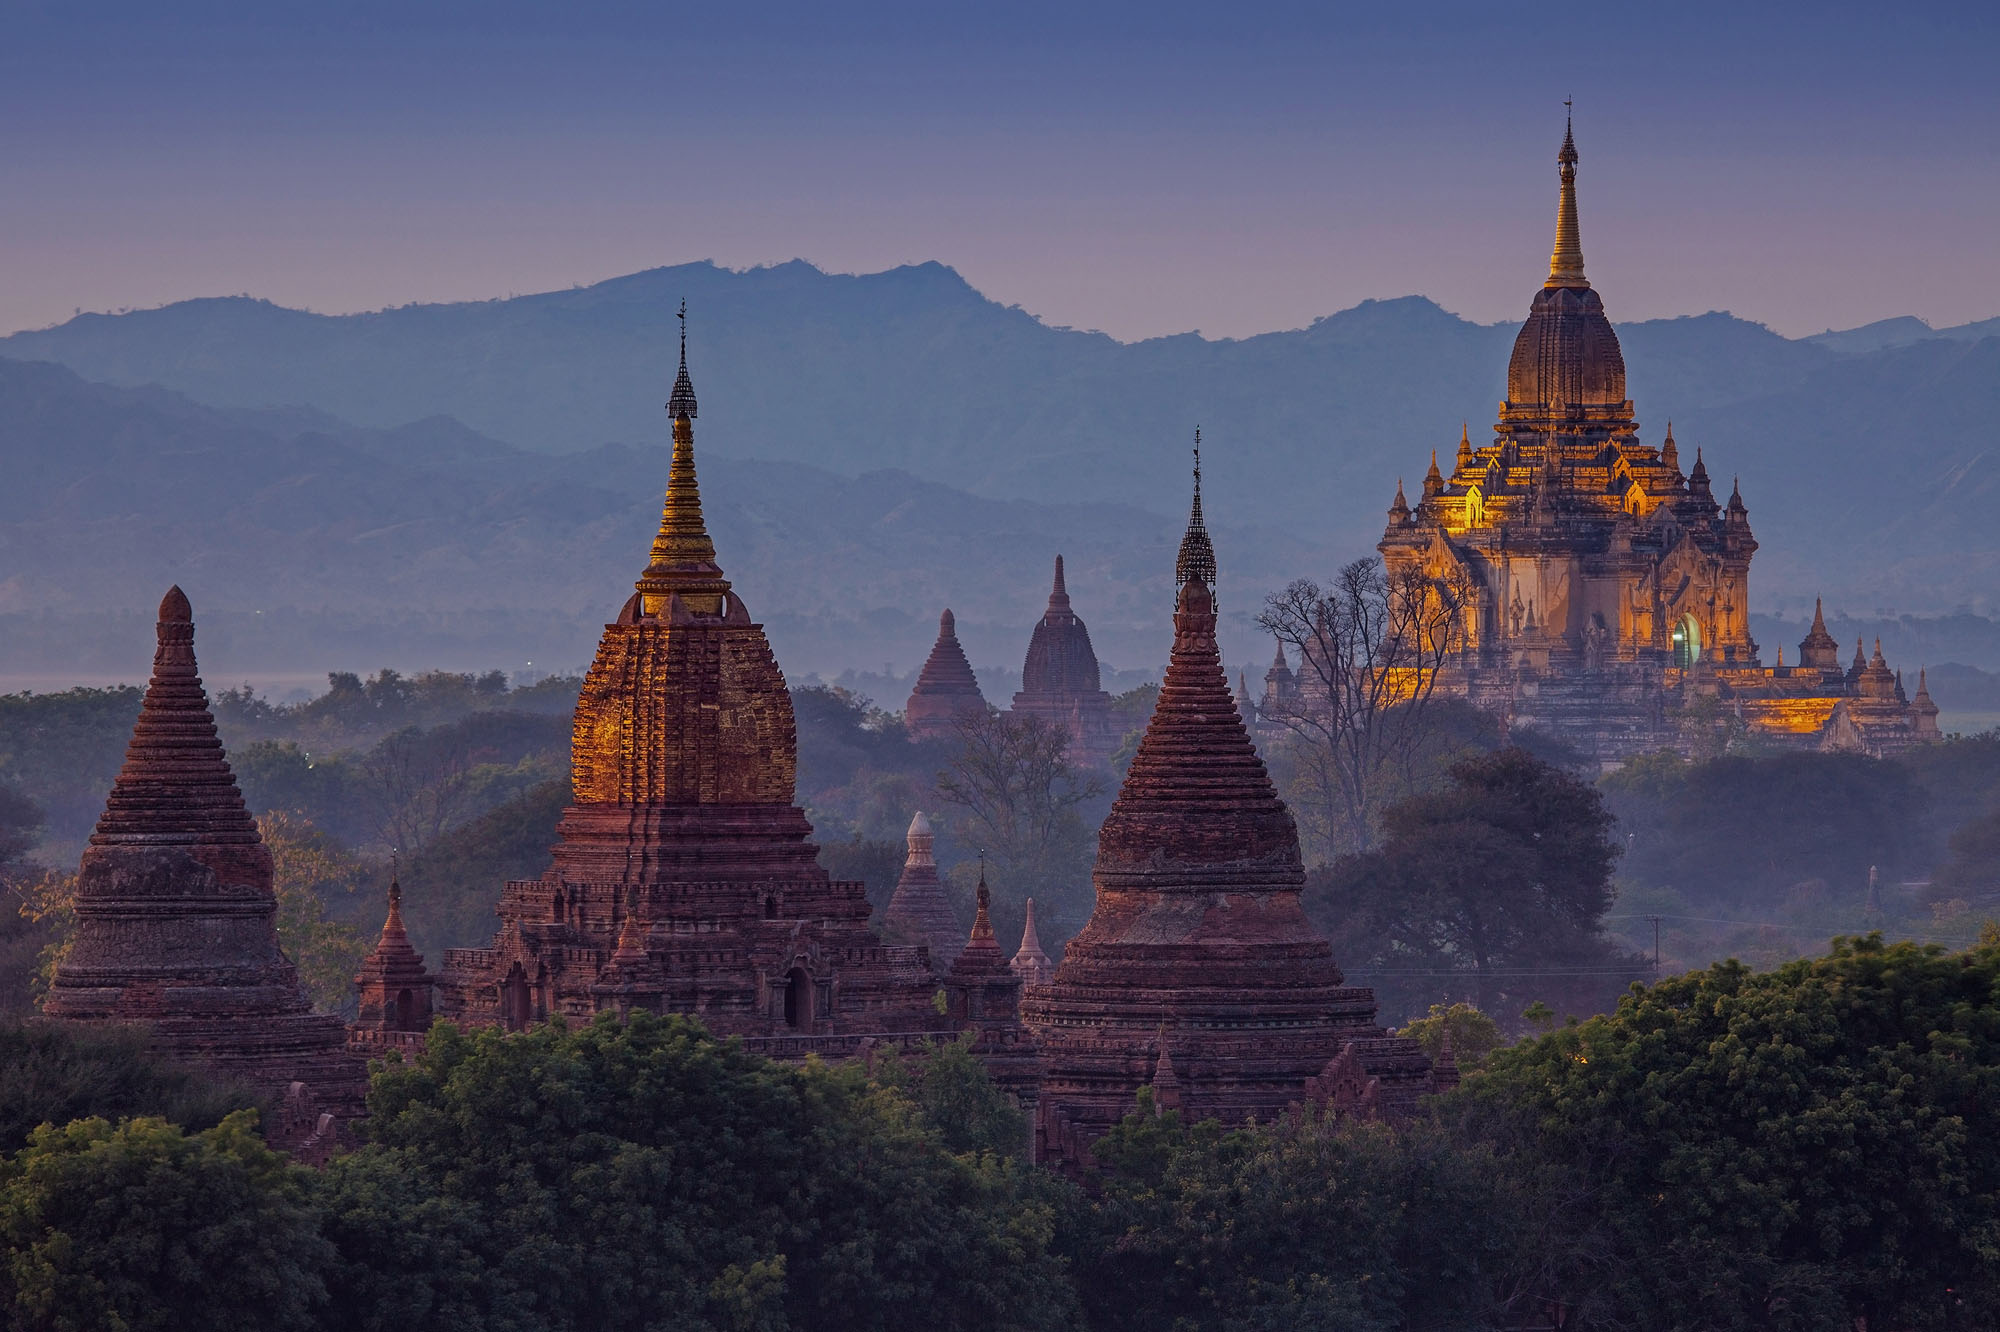Can you craft a short poem inspired by this breathtaking view? In Bagan’s ancient heart, where temples rise,
Golden spires kiss the twilight skies,
In whispers soft, the past does speak,
Of monks and pilgrims, humble, meek.
The mountains cradle, fields embrace,
A sacred dance of time and space,
Bathed in hues of purple hue,
A timeless tale in sunset’s view. 